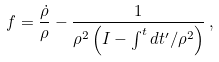<formula> <loc_0><loc_0><loc_500><loc_500>f = \frac { \dot { \rho } } { \rho } - \frac { 1 } { \rho ^ { 2 } \left ( I - \int ^ { t } d t ^ { \prime } / \rho ^ { 2 } \right ) } \, ,</formula> 